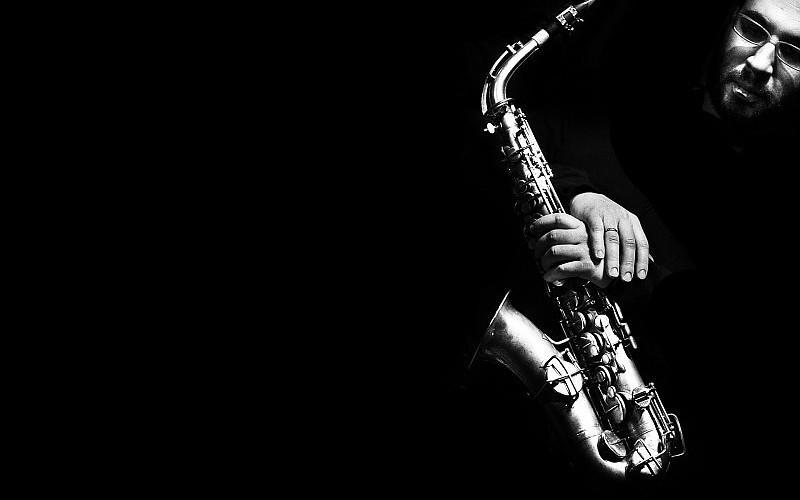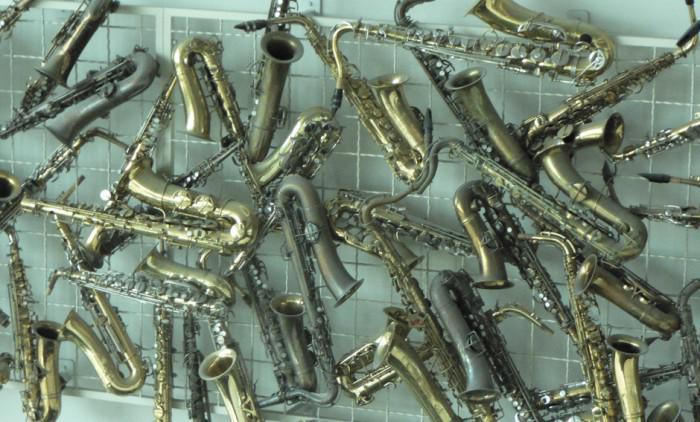The first image is the image on the left, the second image is the image on the right. Evaluate the accuracy of this statement regarding the images: "One image is in color, while the other is a black and white photo of a person holding a saxophone.". Is it true? Answer yes or no. Yes. 